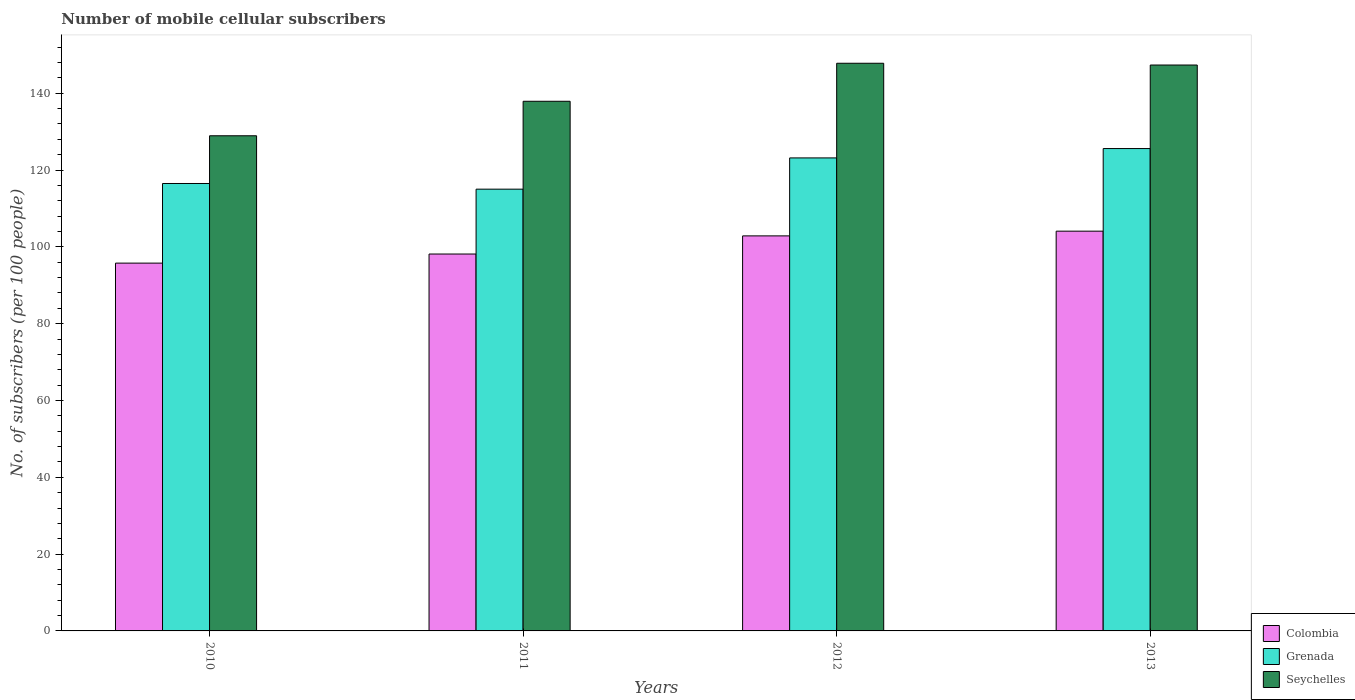How many different coloured bars are there?
Offer a very short reply. 3. How many groups of bars are there?
Provide a succinct answer. 4. Are the number of bars on each tick of the X-axis equal?
Your answer should be very brief. Yes. How many bars are there on the 2nd tick from the right?
Offer a terse response. 3. In how many cases, is the number of bars for a given year not equal to the number of legend labels?
Ensure brevity in your answer.  0. What is the number of mobile cellular subscribers in Seychelles in 2011?
Your answer should be compact. 137.9. Across all years, what is the maximum number of mobile cellular subscribers in Colombia?
Offer a very short reply. 104.08. Across all years, what is the minimum number of mobile cellular subscribers in Grenada?
Offer a terse response. 115.02. In which year was the number of mobile cellular subscribers in Seychelles minimum?
Give a very brief answer. 2010. What is the total number of mobile cellular subscribers in Grenada in the graph?
Keep it short and to the point. 480.27. What is the difference between the number of mobile cellular subscribers in Grenada in 2010 and that in 2012?
Offer a very short reply. -6.66. What is the difference between the number of mobile cellular subscribers in Seychelles in 2010 and the number of mobile cellular subscribers in Grenada in 2013?
Provide a short and direct response. 3.33. What is the average number of mobile cellular subscribers in Colombia per year?
Your response must be concise. 100.21. In the year 2010, what is the difference between the number of mobile cellular subscribers in Grenada and number of mobile cellular subscribers in Seychelles?
Provide a succinct answer. -12.42. What is the ratio of the number of mobile cellular subscribers in Seychelles in 2012 to that in 2013?
Give a very brief answer. 1. Is the number of mobile cellular subscribers in Seychelles in 2010 less than that in 2013?
Your answer should be compact. Yes. Is the difference between the number of mobile cellular subscribers in Grenada in 2010 and 2011 greater than the difference between the number of mobile cellular subscribers in Seychelles in 2010 and 2011?
Give a very brief answer. Yes. What is the difference between the highest and the second highest number of mobile cellular subscribers in Grenada?
Ensure brevity in your answer.  2.43. What is the difference between the highest and the lowest number of mobile cellular subscribers in Grenada?
Give a very brief answer. 10.57. In how many years, is the number of mobile cellular subscribers in Colombia greater than the average number of mobile cellular subscribers in Colombia taken over all years?
Offer a terse response. 2. Is the sum of the number of mobile cellular subscribers in Grenada in 2010 and 2013 greater than the maximum number of mobile cellular subscribers in Colombia across all years?
Provide a succinct answer. Yes. What does the 1st bar from the right in 2012 represents?
Provide a short and direct response. Seychelles. Are the values on the major ticks of Y-axis written in scientific E-notation?
Keep it short and to the point. No. Does the graph contain any zero values?
Offer a terse response. No. How many legend labels are there?
Provide a short and direct response. 3. How are the legend labels stacked?
Your answer should be very brief. Vertical. What is the title of the graph?
Make the answer very short. Number of mobile cellular subscribers. Does "Sierra Leone" appear as one of the legend labels in the graph?
Make the answer very short. No. What is the label or title of the Y-axis?
Your answer should be compact. No. of subscribers (per 100 people). What is the No. of subscribers (per 100 people) in Colombia in 2010?
Your answer should be compact. 95.76. What is the No. of subscribers (per 100 people) in Grenada in 2010?
Give a very brief answer. 116.5. What is the No. of subscribers (per 100 people) in Seychelles in 2010?
Ensure brevity in your answer.  128.92. What is the No. of subscribers (per 100 people) in Colombia in 2011?
Your answer should be compact. 98.13. What is the No. of subscribers (per 100 people) in Grenada in 2011?
Your answer should be very brief. 115.02. What is the No. of subscribers (per 100 people) in Seychelles in 2011?
Provide a succinct answer. 137.9. What is the No. of subscribers (per 100 people) of Colombia in 2012?
Offer a terse response. 102.85. What is the No. of subscribers (per 100 people) of Grenada in 2012?
Give a very brief answer. 123.16. What is the No. of subscribers (per 100 people) of Seychelles in 2012?
Your answer should be very brief. 147.8. What is the No. of subscribers (per 100 people) in Colombia in 2013?
Your answer should be compact. 104.08. What is the No. of subscribers (per 100 people) of Grenada in 2013?
Provide a short and direct response. 125.59. What is the No. of subscribers (per 100 people) in Seychelles in 2013?
Your answer should be compact. 147.34. Across all years, what is the maximum No. of subscribers (per 100 people) of Colombia?
Offer a terse response. 104.08. Across all years, what is the maximum No. of subscribers (per 100 people) in Grenada?
Make the answer very short. 125.59. Across all years, what is the maximum No. of subscribers (per 100 people) of Seychelles?
Ensure brevity in your answer.  147.8. Across all years, what is the minimum No. of subscribers (per 100 people) in Colombia?
Offer a very short reply. 95.76. Across all years, what is the minimum No. of subscribers (per 100 people) in Grenada?
Your answer should be very brief. 115.02. Across all years, what is the minimum No. of subscribers (per 100 people) in Seychelles?
Provide a short and direct response. 128.92. What is the total No. of subscribers (per 100 people) in Colombia in the graph?
Give a very brief answer. 400.84. What is the total No. of subscribers (per 100 people) of Grenada in the graph?
Your answer should be compact. 480.27. What is the total No. of subscribers (per 100 people) in Seychelles in the graph?
Keep it short and to the point. 561.97. What is the difference between the No. of subscribers (per 100 people) in Colombia in 2010 and that in 2011?
Make the answer very short. -2.37. What is the difference between the No. of subscribers (per 100 people) of Grenada in 2010 and that in 2011?
Give a very brief answer. 1.48. What is the difference between the No. of subscribers (per 100 people) in Seychelles in 2010 and that in 2011?
Ensure brevity in your answer.  -8.98. What is the difference between the No. of subscribers (per 100 people) in Colombia in 2010 and that in 2012?
Offer a very short reply. -7.09. What is the difference between the No. of subscribers (per 100 people) of Grenada in 2010 and that in 2012?
Give a very brief answer. -6.66. What is the difference between the No. of subscribers (per 100 people) of Seychelles in 2010 and that in 2012?
Keep it short and to the point. -18.88. What is the difference between the No. of subscribers (per 100 people) in Colombia in 2010 and that in 2013?
Offer a very short reply. -8.32. What is the difference between the No. of subscribers (per 100 people) in Grenada in 2010 and that in 2013?
Provide a short and direct response. -9.1. What is the difference between the No. of subscribers (per 100 people) of Seychelles in 2010 and that in 2013?
Keep it short and to the point. -18.42. What is the difference between the No. of subscribers (per 100 people) in Colombia in 2011 and that in 2012?
Provide a short and direct response. -4.72. What is the difference between the No. of subscribers (per 100 people) of Grenada in 2011 and that in 2012?
Your answer should be compact. -8.14. What is the difference between the No. of subscribers (per 100 people) of Seychelles in 2011 and that in 2012?
Offer a terse response. -9.9. What is the difference between the No. of subscribers (per 100 people) of Colombia in 2011 and that in 2013?
Keep it short and to the point. -5.95. What is the difference between the No. of subscribers (per 100 people) of Grenada in 2011 and that in 2013?
Your answer should be compact. -10.57. What is the difference between the No. of subscribers (per 100 people) in Seychelles in 2011 and that in 2013?
Your response must be concise. -9.44. What is the difference between the No. of subscribers (per 100 people) in Colombia in 2012 and that in 2013?
Provide a succinct answer. -1.23. What is the difference between the No. of subscribers (per 100 people) of Grenada in 2012 and that in 2013?
Provide a short and direct response. -2.43. What is the difference between the No. of subscribers (per 100 people) in Seychelles in 2012 and that in 2013?
Your answer should be very brief. 0.46. What is the difference between the No. of subscribers (per 100 people) of Colombia in 2010 and the No. of subscribers (per 100 people) of Grenada in 2011?
Your response must be concise. -19.25. What is the difference between the No. of subscribers (per 100 people) of Colombia in 2010 and the No. of subscribers (per 100 people) of Seychelles in 2011?
Your answer should be compact. -42.14. What is the difference between the No. of subscribers (per 100 people) in Grenada in 2010 and the No. of subscribers (per 100 people) in Seychelles in 2011?
Your answer should be compact. -21.41. What is the difference between the No. of subscribers (per 100 people) of Colombia in 2010 and the No. of subscribers (per 100 people) of Grenada in 2012?
Your answer should be very brief. -27.39. What is the difference between the No. of subscribers (per 100 people) of Colombia in 2010 and the No. of subscribers (per 100 people) of Seychelles in 2012?
Provide a succinct answer. -52.04. What is the difference between the No. of subscribers (per 100 people) of Grenada in 2010 and the No. of subscribers (per 100 people) of Seychelles in 2012?
Provide a succinct answer. -31.31. What is the difference between the No. of subscribers (per 100 people) of Colombia in 2010 and the No. of subscribers (per 100 people) of Grenada in 2013?
Keep it short and to the point. -29.83. What is the difference between the No. of subscribers (per 100 people) of Colombia in 2010 and the No. of subscribers (per 100 people) of Seychelles in 2013?
Your answer should be very brief. -51.58. What is the difference between the No. of subscribers (per 100 people) of Grenada in 2010 and the No. of subscribers (per 100 people) of Seychelles in 2013?
Provide a short and direct response. -30.85. What is the difference between the No. of subscribers (per 100 people) in Colombia in 2011 and the No. of subscribers (per 100 people) in Grenada in 2012?
Your response must be concise. -25.02. What is the difference between the No. of subscribers (per 100 people) in Colombia in 2011 and the No. of subscribers (per 100 people) in Seychelles in 2012?
Make the answer very short. -49.67. What is the difference between the No. of subscribers (per 100 people) in Grenada in 2011 and the No. of subscribers (per 100 people) in Seychelles in 2012?
Your answer should be very brief. -32.78. What is the difference between the No. of subscribers (per 100 people) in Colombia in 2011 and the No. of subscribers (per 100 people) in Grenada in 2013?
Offer a terse response. -27.46. What is the difference between the No. of subscribers (per 100 people) of Colombia in 2011 and the No. of subscribers (per 100 people) of Seychelles in 2013?
Give a very brief answer. -49.21. What is the difference between the No. of subscribers (per 100 people) in Grenada in 2011 and the No. of subscribers (per 100 people) in Seychelles in 2013?
Provide a succinct answer. -32.32. What is the difference between the No. of subscribers (per 100 people) of Colombia in 2012 and the No. of subscribers (per 100 people) of Grenada in 2013?
Keep it short and to the point. -22.74. What is the difference between the No. of subscribers (per 100 people) in Colombia in 2012 and the No. of subscribers (per 100 people) in Seychelles in 2013?
Give a very brief answer. -44.49. What is the difference between the No. of subscribers (per 100 people) in Grenada in 2012 and the No. of subscribers (per 100 people) in Seychelles in 2013?
Ensure brevity in your answer.  -24.18. What is the average No. of subscribers (per 100 people) in Colombia per year?
Offer a terse response. 100.21. What is the average No. of subscribers (per 100 people) in Grenada per year?
Give a very brief answer. 120.07. What is the average No. of subscribers (per 100 people) of Seychelles per year?
Offer a very short reply. 140.49. In the year 2010, what is the difference between the No. of subscribers (per 100 people) of Colombia and No. of subscribers (per 100 people) of Grenada?
Provide a short and direct response. -20.73. In the year 2010, what is the difference between the No. of subscribers (per 100 people) in Colombia and No. of subscribers (per 100 people) in Seychelles?
Your response must be concise. -33.16. In the year 2010, what is the difference between the No. of subscribers (per 100 people) in Grenada and No. of subscribers (per 100 people) in Seychelles?
Offer a terse response. -12.42. In the year 2011, what is the difference between the No. of subscribers (per 100 people) in Colombia and No. of subscribers (per 100 people) in Grenada?
Offer a terse response. -16.88. In the year 2011, what is the difference between the No. of subscribers (per 100 people) of Colombia and No. of subscribers (per 100 people) of Seychelles?
Make the answer very short. -39.77. In the year 2011, what is the difference between the No. of subscribers (per 100 people) of Grenada and No. of subscribers (per 100 people) of Seychelles?
Your answer should be compact. -22.88. In the year 2012, what is the difference between the No. of subscribers (per 100 people) of Colombia and No. of subscribers (per 100 people) of Grenada?
Provide a short and direct response. -20.3. In the year 2012, what is the difference between the No. of subscribers (per 100 people) of Colombia and No. of subscribers (per 100 people) of Seychelles?
Give a very brief answer. -44.95. In the year 2012, what is the difference between the No. of subscribers (per 100 people) in Grenada and No. of subscribers (per 100 people) in Seychelles?
Your answer should be very brief. -24.64. In the year 2013, what is the difference between the No. of subscribers (per 100 people) of Colombia and No. of subscribers (per 100 people) of Grenada?
Offer a very short reply. -21.51. In the year 2013, what is the difference between the No. of subscribers (per 100 people) in Colombia and No. of subscribers (per 100 people) in Seychelles?
Keep it short and to the point. -43.26. In the year 2013, what is the difference between the No. of subscribers (per 100 people) of Grenada and No. of subscribers (per 100 people) of Seychelles?
Offer a terse response. -21.75. What is the ratio of the No. of subscribers (per 100 people) in Colombia in 2010 to that in 2011?
Make the answer very short. 0.98. What is the ratio of the No. of subscribers (per 100 people) in Grenada in 2010 to that in 2011?
Offer a very short reply. 1.01. What is the ratio of the No. of subscribers (per 100 people) of Seychelles in 2010 to that in 2011?
Provide a short and direct response. 0.93. What is the ratio of the No. of subscribers (per 100 people) in Colombia in 2010 to that in 2012?
Offer a terse response. 0.93. What is the ratio of the No. of subscribers (per 100 people) in Grenada in 2010 to that in 2012?
Provide a short and direct response. 0.95. What is the ratio of the No. of subscribers (per 100 people) in Seychelles in 2010 to that in 2012?
Offer a very short reply. 0.87. What is the ratio of the No. of subscribers (per 100 people) in Colombia in 2010 to that in 2013?
Keep it short and to the point. 0.92. What is the ratio of the No. of subscribers (per 100 people) in Grenada in 2010 to that in 2013?
Ensure brevity in your answer.  0.93. What is the ratio of the No. of subscribers (per 100 people) of Colombia in 2011 to that in 2012?
Provide a succinct answer. 0.95. What is the ratio of the No. of subscribers (per 100 people) in Grenada in 2011 to that in 2012?
Provide a succinct answer. 0.93. What is the ratio of the No. of subscribers (per 100 people) in Seychelles in 2011 to that in 2012?
Ensure brevity in your answer.  0.93. What is the ratio of the No. of subscribers (per 100 people) of Colombia in 2011 to that in 2013?
Give a very brief answer. 0.94. What is the ratio of the No. of subscribers (per 100 people) in Grenada in 2011 to that in 2013?
Give a very brief answer. 0.92. What is the ratio of the No. of subscribers (per 100 people) of Seychelles in 2011 to that in 2013?
Give a very brief answer. 0.94. What is the ratio of the No. of subscribers (per 100 people) in Grenada in 2012 to that in 2013?
Your answer should be very brief. 0.98. What is the ratio of the No. of subscribers (per 100 people) in Seychelles in 2012 to that in 2013?
Make the answer very short. 1. What is the difference between the highest and the second highest No. of subscribers (per 100 people) of Colombia?
Make the answer very short. 1.23. What is the difference between the highest and the second highest No. of subscribers (per 100 people) of Grenada?
Give a very brief answer. 2.43. What is the difference between the highest and the second highest No. of subscribers (per 100 people) in Seychelles?
Your response must be concise. 0.46. What is the difference between the highest and the lowest No. of subscribers (per 100 people) of Colombia?
Offer a terse response. 8.32. What is the difference between the highest and the lowest No. of subscribers (per 100 people) of Grenada?
Keep it short and to the point. 10.57. What is the difference between the highest and the lowest No. of subscribers (per 100 people) in Seychelles?
Provide a short and direct response. 18.88. 